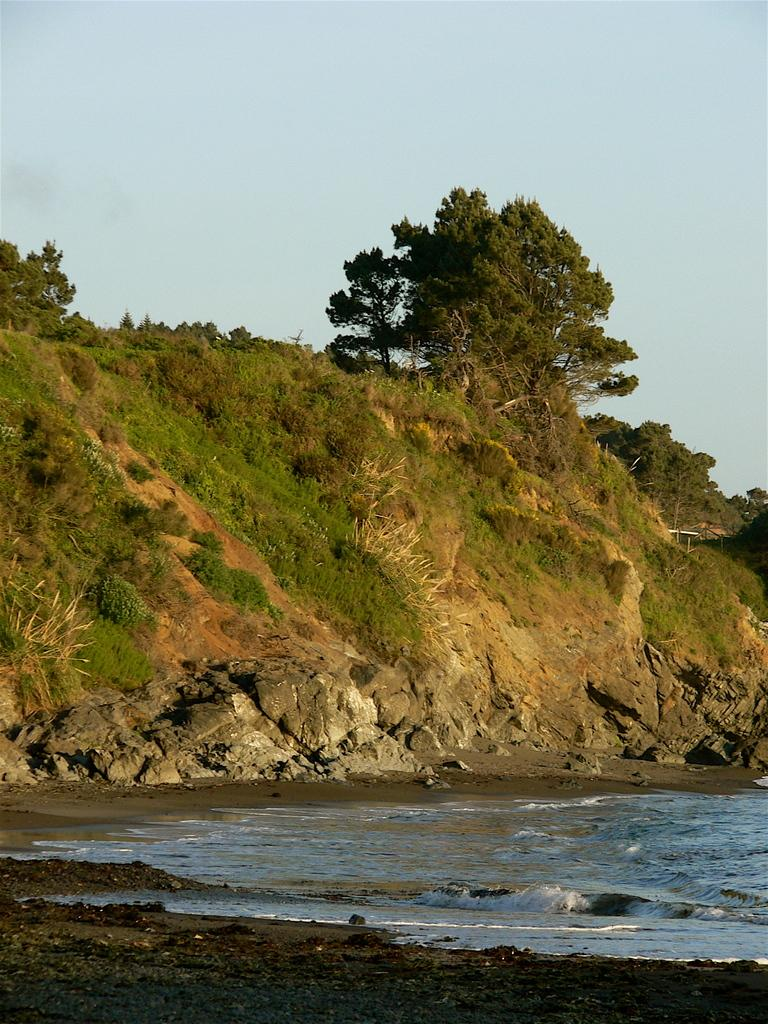What type of vegetation can be seen in the image? There are trees, plants, and grass visible in the image. What natural element is present in the image? Water is visible in the image. What can be seen in the background of the image? The sky is visible in the background of the image. What type of business is being conducted in the image? There is no indication of any business activity in the image; it primarily features natural elements and vegetation. 